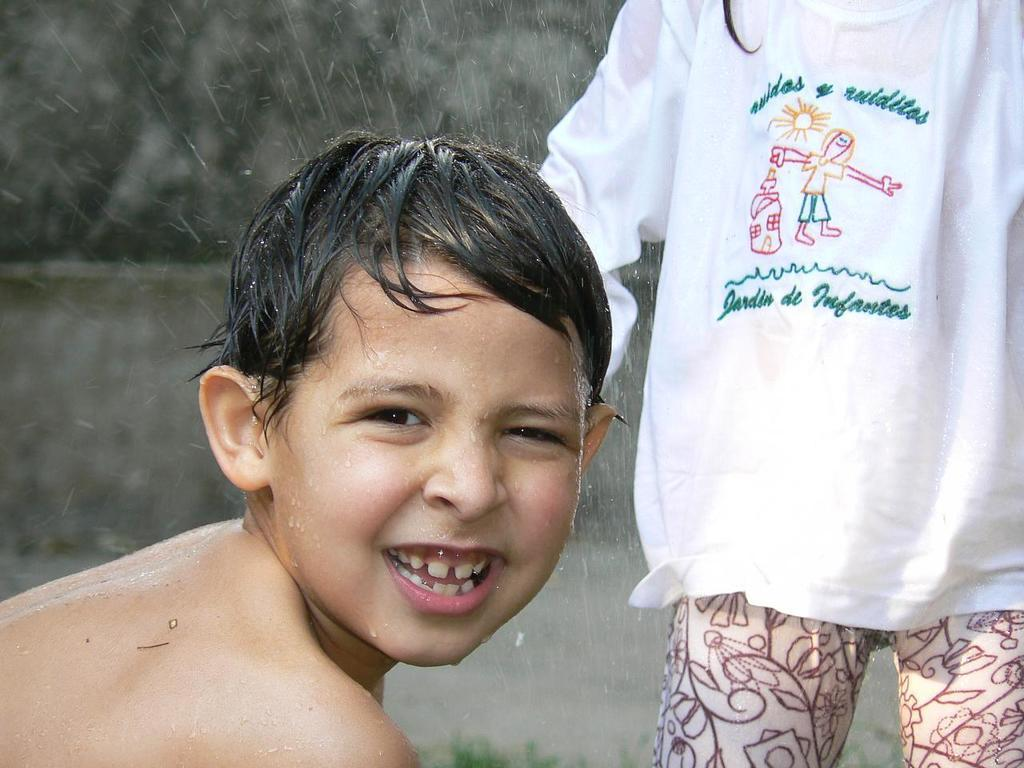What is the main subject of the image? There is a boy in the image. What is the boy's facial expression? The boy is smiling. Can you describe the person standing behind the boy? Unfortunately, the provided facts do not give any information about the person standing behind the boy. Can you tell me how many babies are swimming in the river behind the boy? There is no river or babies present in the image; it only features a boy and a person standing behind him. 